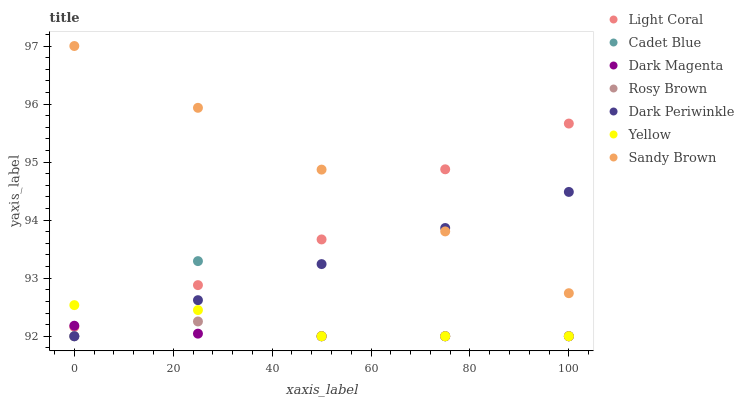Does Dark Magenta have the minimum area under the curve?
Answer yes or no. Yes. Does Sandy Brown have the maximum area under the curve?
Answer yes or no. Yes. Does Rosy Brown have the minimum area under the curve?
Answer yes or no. No. Does Rosy Brown have the maximum area under the curve?
Answer yes or no. No. Is Dark Periwinkle the smoothest?
Answer yes or no. Yes. Is Cadet Blue the roughest?
Answer yes or no. Yes. Is Dark Magenta the smoothest?
Answer yes or no. No. Is Dark Magenta the roughest?
Answer yes or no. No. Does Cadet Blue have the lowest value?
Answer yes or no. Yes. Does Light Coral have the lowest value?
Answer yes or no. No. Does Sandy Brown have the highest value?
Answer yes or no. Yes. Does Rosy Brown have the highest value?
Answer yes or no. No. Is Yellow less than Sandy Brown?
Answer yes or no. Yes. Is Sandy Brown greater than Dark Magenta?
Answer yes or no. Yes. Does Cadet Blue intersect Dark Periwinkle?
Answer yes or no. Yes. Is Cadet Blue less than Dark Periwinkle?
Answer yes or no. No. Is Cadet Blue greater than Dark Periwinkle?
Answer yes or no. No. Does Yellow intersect Sandy Brown?
Answer yes or no. No. 